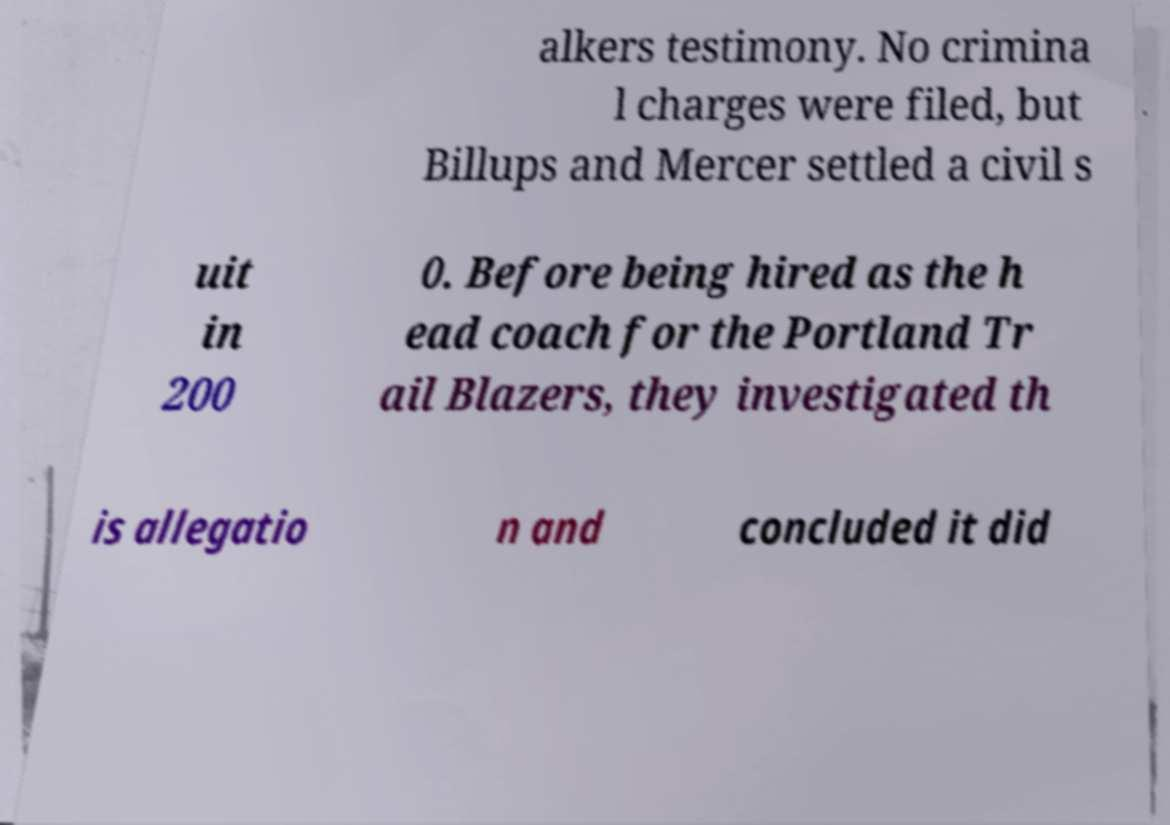Could you assist in decoding the text presented in this image and type it out clearly? alkers testimony. No crimina l charges were filed, but Billups and Mercer settled a civil s uit in 200 0. Before being hired as the h ead coach for the Portland Tr ail Blazers, they investigated th is allegatio n and concluded it did 